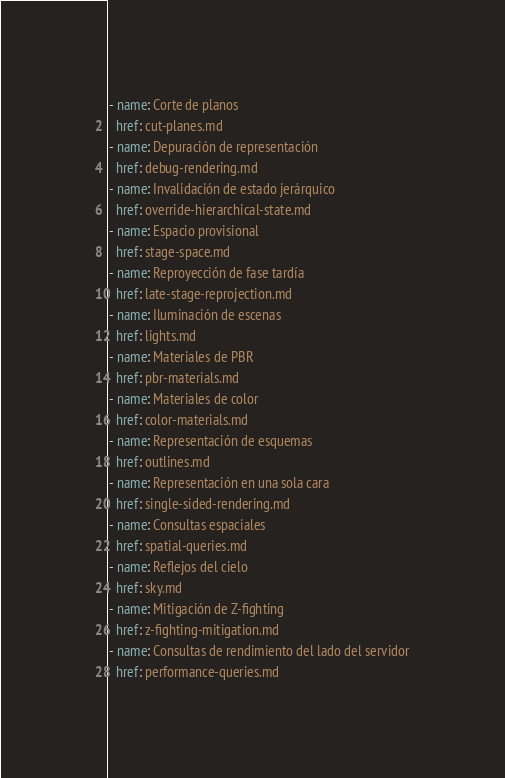Convert code to text. <code><loc_0><loc_0><loc_500><loc_500><_YAML_>- name: Corte de planos
  href: cut-planes.md
- name: Depuración de representación
  href: debug-rendering.md
- name: Invalidación de estado jerárquico
  href: override-hierarchical-state.md
- name: Espacio provisional
  href: stage-space.md
- name: Reproyección de fase tardía
  href: late-stage-reprojection.md
- name: Iluminación de escenas
  href: lights.md
- name: Materiales de PBR
  href: pbr-materials.md
- name: Materiales de color
  href: color-materials.md
- name: Representación de esquemas
  href: outlines.md
- name: Representación en una sola cara
  href: single-sided-rendering.md
- name: Consultas espaciales
  href: spatial-queries.md
- name: Reflejos del cielo
  href: sky.md
- name: Mitigación de Z-fighting
  href: z-fighting-mitigation.md
- name: Consultas de rendimiento del lado del servidor
  href: performance-queries.md</code> 